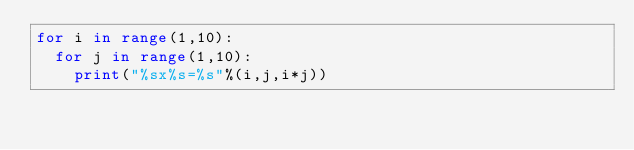<code> <loc_0><loc_0><loc_500><loc_500><_Python_>for i in range(1,10):
  for j in range(1,10):
    print("%sx%s=%s"%(i,j,i*j))
</code> 